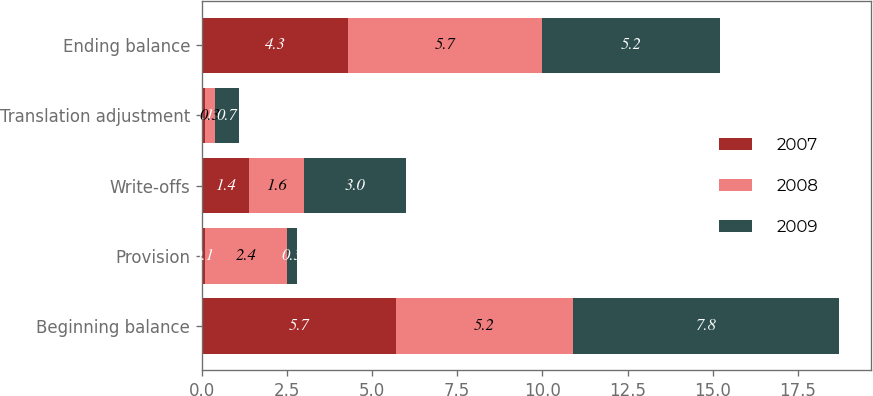Convert chart. <chart><loc_0><loc_0><loc_500><loc_500><stacked_bar_chart><ecel><fcel>Beginning balance<fcel>Provision<fcel>Write-offs<fcel>Translation adjustment<fcel>Ending balance<nl><fcel>2007<fcel>5.7<fcel>0.1<fcel>1.4<fcel>0.1<fcel>4.3<nl><fcel>2008<fcel>5.2<fcel>2.4<fcel>1.6<fcel>0.3<fcel>5.7<nl><fcel>2009<fcel>7.8<fcel>0.3<fcel>3<fcel>0.7<fcel>5.2<nl></chart> 